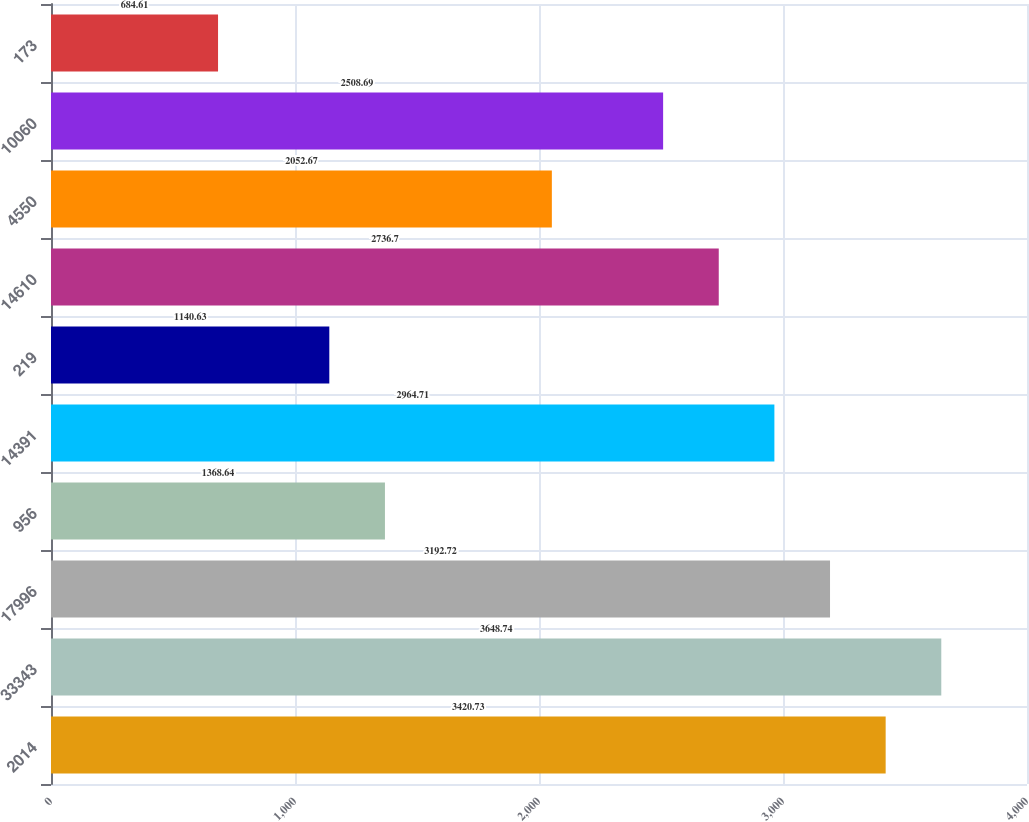Convert chart. <chart><loc_0><loc_0><loc_500><loc_500><bar_chart><fcel>2014<fcel>33343<fcel>17996<fcel>956<fcel>14391<fcel>219<fcel>14610<fcel>4550<fcel>10060<fcel>173<nl><fcel>3420.73<fcel>3648.74<fcel>3192.72<fcel>1368.64<fcel>2964.71<fcel>1140.63<fcel>2736.7<fcel>2052.67<fcel>2508.69<fcel>684.61<nl></chart> 